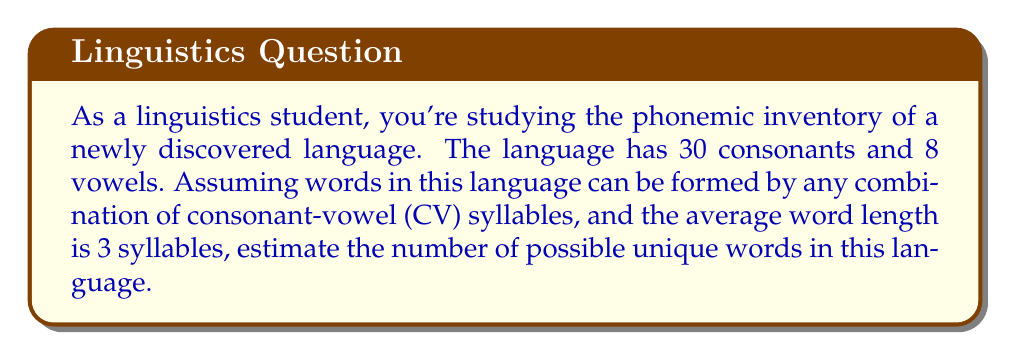Help me with this question. Let's approach this step-by-step:

1) First, we need to calculate the number of possible CV syllables:
   $$ \text{Number of syllables} = \text{Number of consonants} \times \text{Number of vowels} $$
   $$ = 30 \times 8 = 240 $$

2) Now, we need to consider that the average word length is 3 syllables. This means we're looking at combinations with repetition, where the order matters.

3) The formula for this is:
   $$ \text{Number of possibilities} = n^r $$
   Where $n$ is the number of options for each position, and $r$ is the number of positions.

4) In our case:
   $n = 240$ (number of possible syllables)
   $r = 3$ (average number of syllables per word)

5) So, we can estimate the number of possible words as:
   $$ \text{Number of possible words} = 240^3 $$

6) Let's calculate this:
   $$ 240^3 = 240 \times 240 \times 240 = 13,824,000 $$

Therefore, we estimate that this language could potentially have around 13,824,000 unique words.
Answer: $$ 13,824,000 \text{ possible unique words} $$ 